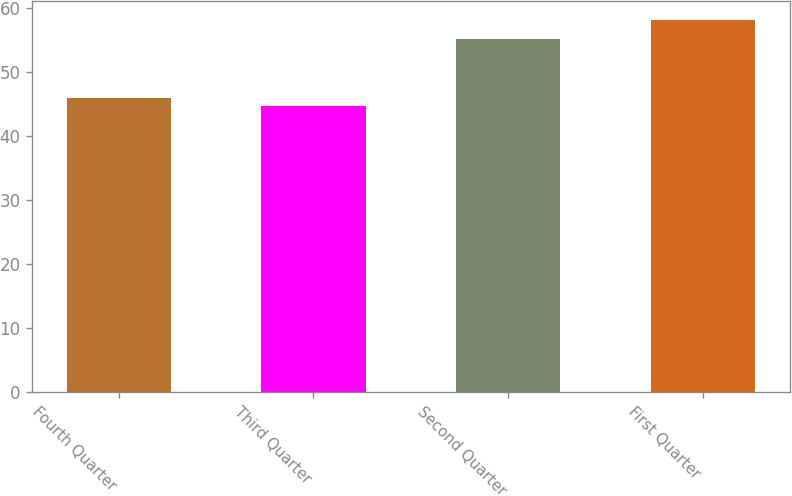Convert chart to OTSL. <chart><loc_0><loc_0><loc_500><loc_500><bar_chart><fcel>Fourth Quarter<fcel>Third Quarter<fcel>Second Quarter<fcel>First Quarter<nl><fcel>46.05<fcel>44.7<fcel>55.25<fcel>58.19<nl></chart> 